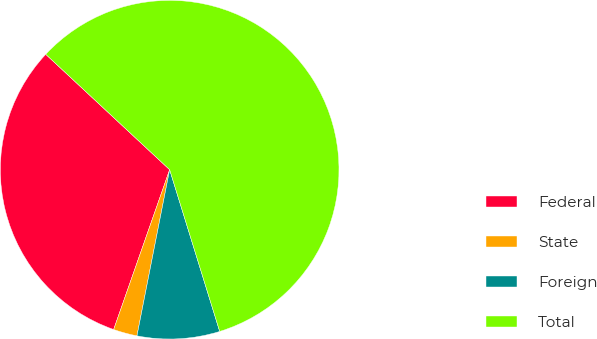<chart> <loc_0><loc_0><loc_500><loc_500><pie_chart><fcel>Federal<fcel>State<fcel>Foreign<fcel>Total<nl><fcel>31.57%<fcel>2.27%<fcel>7.87%<fcel>58.29%<nl></chart> 